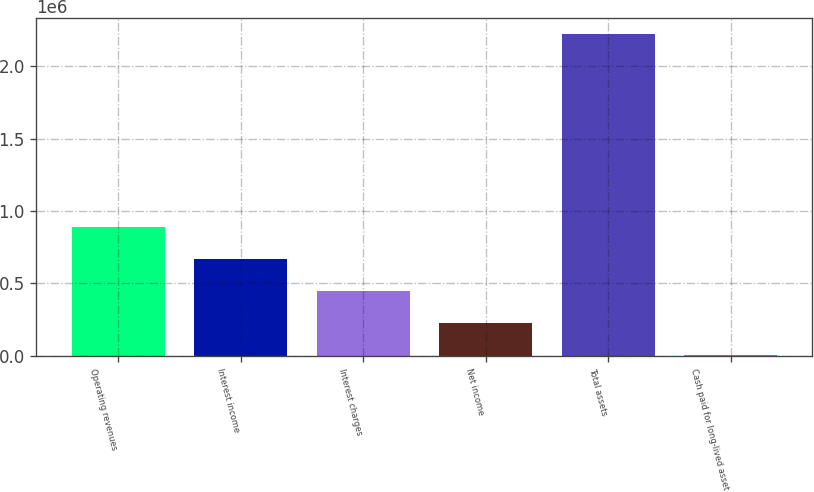<chart> <loc_0><loc_0><loc_500><loc_500><bar_chart><fcel>Operating revenues<fcel>Interest income<fcel>Interest charges<fcel>Net income<fcel>Total assets<fcel>Cash paid for long-lived asset<nl><fcel>890798<fcel>668604<fcel>446410<fcel>224216<fcel>2.22396e+06<fcel>2022<nl></chart> 